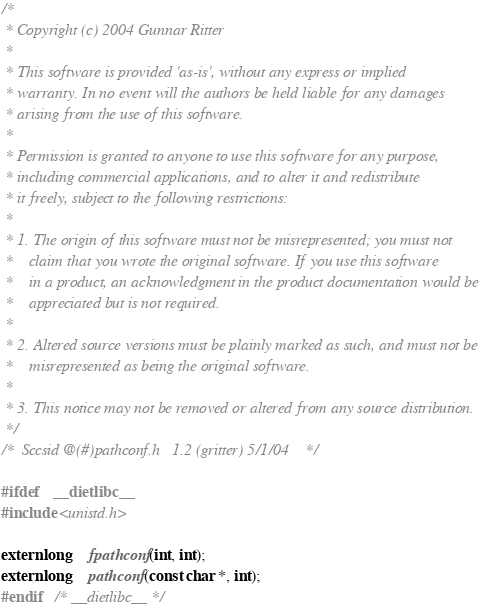<code> <loc_0><loc_0><loc_500><loc_500><_C_>/*
 * Copyright (c) 2004 Gunnar Ritter
 *
 * This software is provided 'as-is', without any express or implied
 * warranty. In no event will the authors be held liable for any damages
 * arising from the use of this software.
 *
 * Permission is granted to anyone to use this software for any purpose,
 * including commercial applications, and to alter it and redistribute
 * it freely, subject to the following restrictions:
 *
 * 1. The origin of this software must not be misrepresented; you must not
 *    claim that you wrote the original software. If you use this software
 *    in a product, an acknowledgment in the product documentation would be
 *    appreciated but is not required.
 *
 * 2. Altered source versions must be plainly marked as such, and must not be
 *    misrepresented as being the original software.
 *
 * 3. This notice may not be removed or altered from any source distribution.
 */
/*	Sccsid @(#)pathconf.h	1.2 (gritter) 5/1/04	*/

#ifdef	__dietlibc__
#include <unistd.h>

extern long	fpathconf(int, int);
extern long	pathconf(const char *, int);
#endif	/* __dietlibc__ */
</code> 